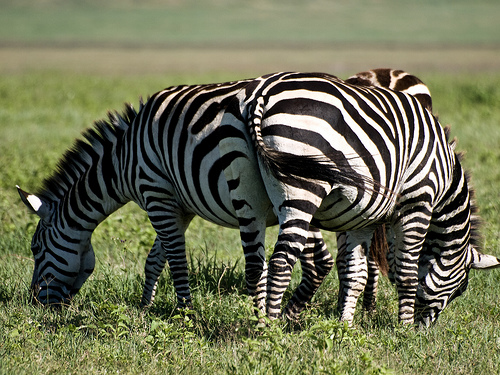Are there zebras to the left of the person? Indeed, there are zebras to the left of the individual in the image. They are grazing in what appears to be a sunny field, showcasing their distinctive black and white striped patterns. 